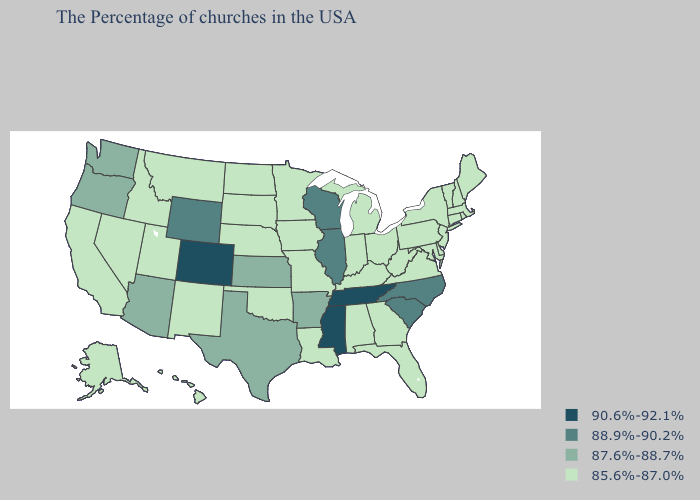What is the value of Oklahoma?
Give a very brief answer. 85.6%-87.0%. Does the first symbol in the legend represent the smallest category?
Concise answer only. No. Which states have the lowest value in the South?
Short answer required. Delaware, Maryland, Virginia, West Virginia, Florida, Georgia, Kentucky, Alabama, Louisiana, Oklahoma. Which states have the highest value in the USA?
Give a very brief answer. Tennessee, Mississippi, Colorado. What is the lowest value in states that border Virginia?
Keep it brief. 85.6%-87.0%. Name the states that have a value in the range 85.6%-87.0%?
Answer briefly. Maine, Massachusetts, Rhode Island, New Hampshire, Vermont, Connecticut, New York, New Jersey, Delaware, Maryland, Pennsylvania, Virginia, West Virginia, Ohio, Florida, Georgia, Michigan, Kentucky, Indiana, Alabama, Louisiana, Missouri, Minnesota, Iowa, Nebraska, Oklahoma, South Dakota, North Dakota, New Mexico, Utah, Montana, Idaho, Nevada, California, Alaska, Hawaii. What is the value of New Jersey?
Short answer required. 85.6%-87.0%. What is the lowest value in the West?
Answer briefly. 85.6%-87.0%. Which states have the highest value in the USA?
Be succinct. Tennessee, Mississippi, Colorado. Is the legend a continuous bar?
Answer briefly. No. Name the states that have a value in the range 88.9%-90.2%?
Give a very brief answer. North Carolina, South Carolina, Wisconsin, Illinois, Wyoming. What is the value of Missouri?
Concise answer only. 85.6%-87.0%. Name the states that have a value in the range 90.6%-92.1%?
Be succinct. Tennessee, Mississippi, Colorado. Does the first symbol in the legend represent the smallest category?
Give a very brief answer. No. Which states hav the highest value in the South?
Keep it brief. Tennessee, Mississippi. 